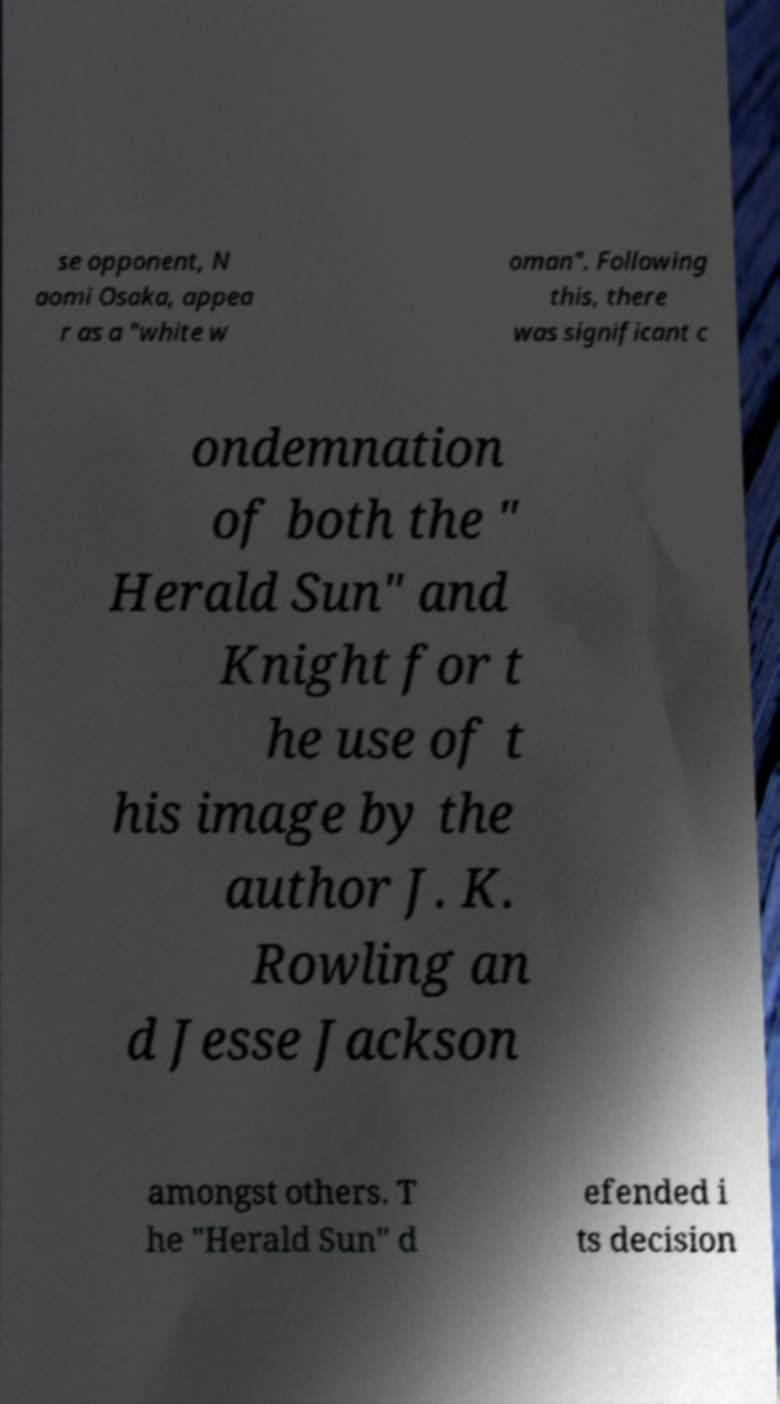For documentation purposes, I need the text within this image transcribed. Could you provide that? se opponent, N aomi Osaka, appea r as a "white w oman". Following this, there was significant c ondemnation of both the " Herald Sun" and Knight for t he use of t his image by the author J. K. Rowling an d Jesse Jackson amongst others. T he "Herald Sun" d efended i ts decision 